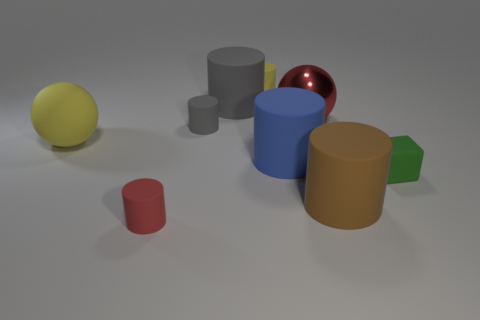Is there any other thing that has the same material as the large red thing?
Offer a terse response. No. There is a big ball that is the same material as the big blue cylinder; what is its color?
Offer a terse response. Yellow. Do the cylinder that is in front of the brown cylinder and the green object have the same size?
Provide a short and direct response. Yes. What number of things are large blue cylinders or gray rubber objects?
Your response must be concise. 3. There is a red object that is on the right side of the red thing that is on the left side of the matte thing that is behind the big gray thing; what is its material?
Give a very brief answer. Metal. There is a red object behind the red cylinder; what is its material?
Your answer should be very brief. Metal. Are there any cyan metal cylinders of the same size as the yellow rubber ball?
Provide a succinct answer. No. There is a tiny cylinder that is in front of the big yellow rubber thing; is its color the same as the metallic object?
Your answer should be compact. Yes. How many gray objects are either rubber cylinders or small blocks?
Give a very brief answer. 2. How many large spheres are the same color as the shiny thing?
Your answer should be compact. 0. 